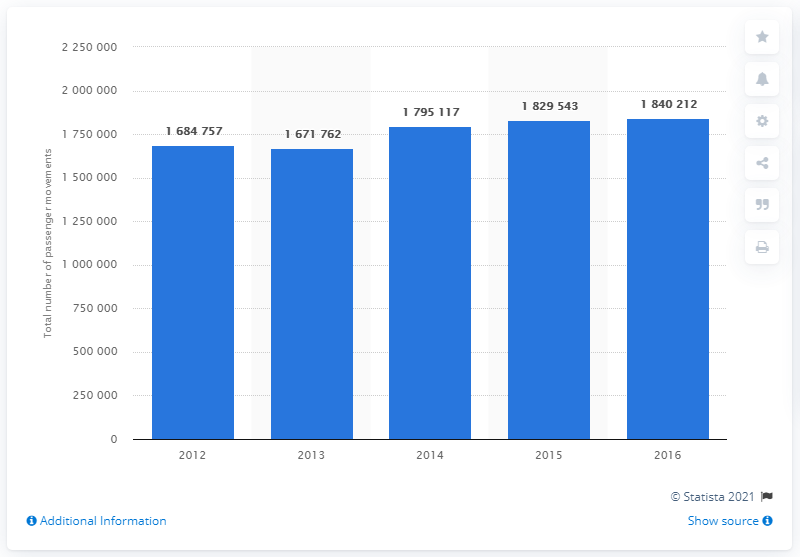Identify some key points in this picture. In 2016, a total of 179,517 passengers passed through Juliana International Airport. In 2013, passenger movements at Princess Juliana International Airport decreased slightly. In 2012, a total of 168,4757 passengers passed through Juliana International Airport. 